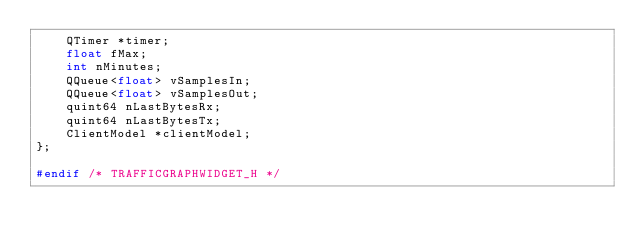<code> <loc_0><loc_0><loc_500><loc_500><_C_>    QTimer *timer;
    float fMax;
    int nMinutes;
    QQueue<float> vSamplesIn;
    QQueue<float> vSamplesOut;
    quint64 nLastBytesRx;
    quint64 nLastBytesTx;
    ClientModel *clientModel;
};

#endif /* TRAFFICGRAPHWIDGET_H */
</code> 